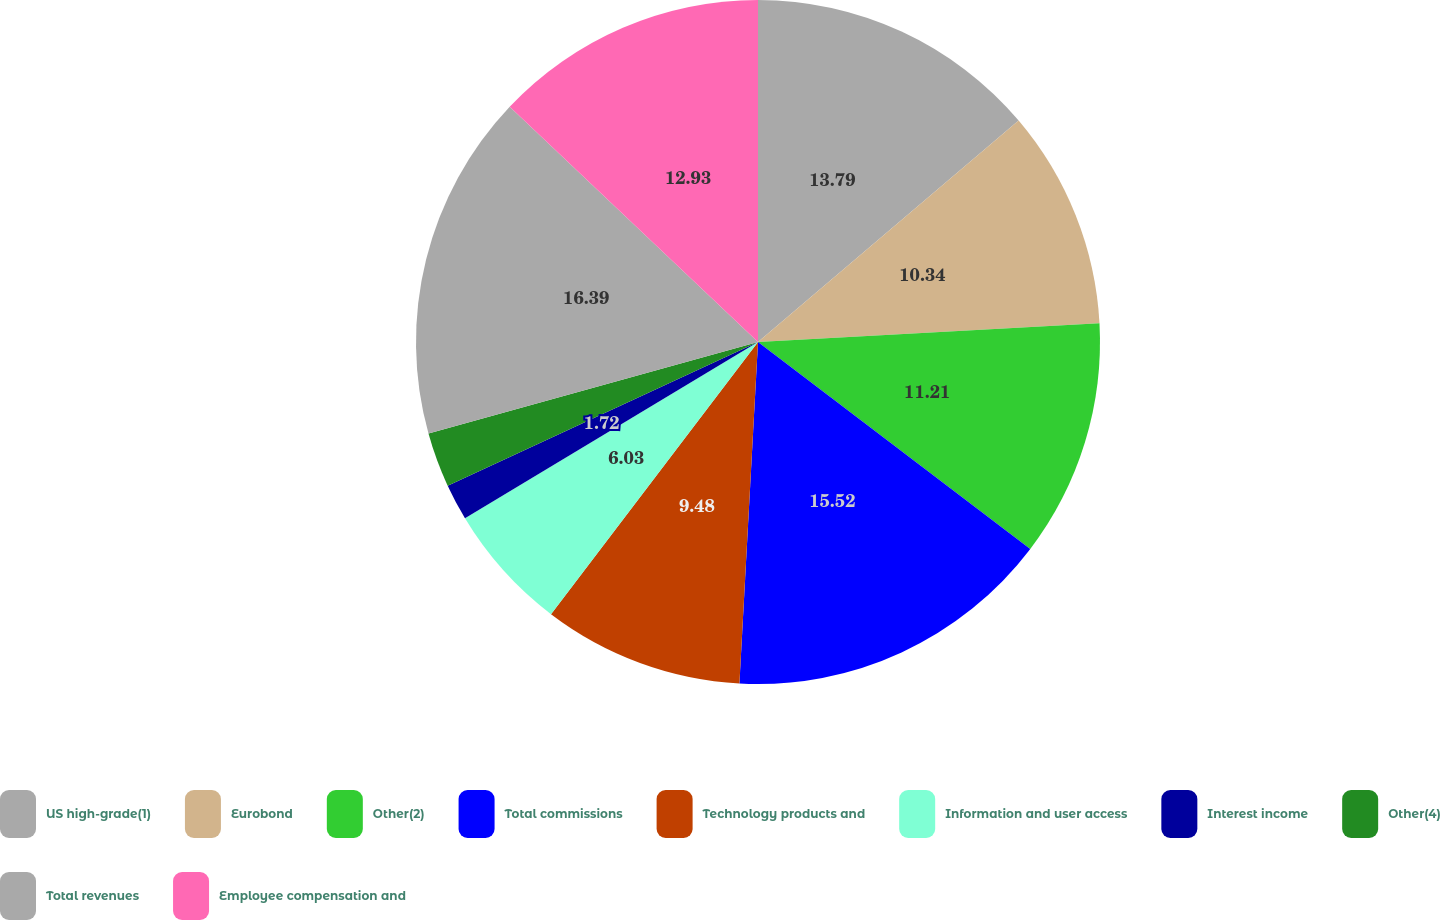Convert chart to OTSL. <chart><loc_0><loc_0><loc_500><loc_500><pie_chart><fcel>US high-grade(1)<fcel>Eurobond<fcel>Other(2)<fcel>Total commissions<fcel>Technology products and<fcel>Information and user access<fcel>Interest income<fcel>Other(4)<fcel>Total revenues<fcel>Employee compensation and<nl><fcel>13.79%<fcel>10.34%<fcel>11.21%<fcel>15.52%<fcel>9.48%<fcel>6.03%<fcel>1.72%<fcel>2.59%<fcel>16.38%<fcel>12.93%<nl></chart> 